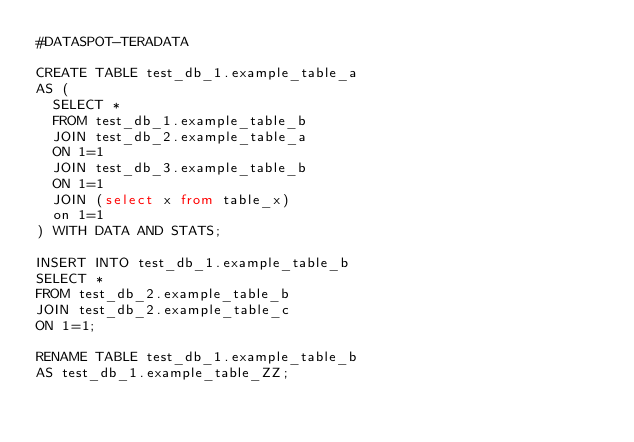Convert code to text. <code><loc_0><loc_0><loc_500><loc_500><_SQL_>#DATASPOT-TERADATA

CREATE TABLE test_db_1.example_table_a
AS (
  SELECT *
  FROM test_db_1.example_table_b
  JOIN test_db_2.example_table_a
  ON 1=1
  JOIN test_db_3.example_table_b
  ON 1=1
  JOIN (select x from table_x)
  on 1=1
) WITH DATA AND STATS;

INSERT INTO test_db_1.example_table_b
SELECT *
FROM test_db_2.example_table_b
JOIN test_db_2.example_table_c
ON 1=1;

RENAME TABLE test_db_1.example_table_b
AS test_db_1.example_table_ZZ;</code> 